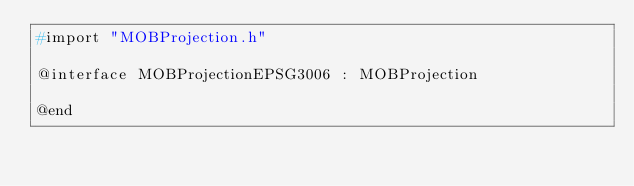Convert code to text. <code><loc_0><loc_0><loc_500><loc_500><_C_>#import "MOBProjection.h"

@interface MOBProjectionEPSG3006 : MOBProjection

@end
</code> 